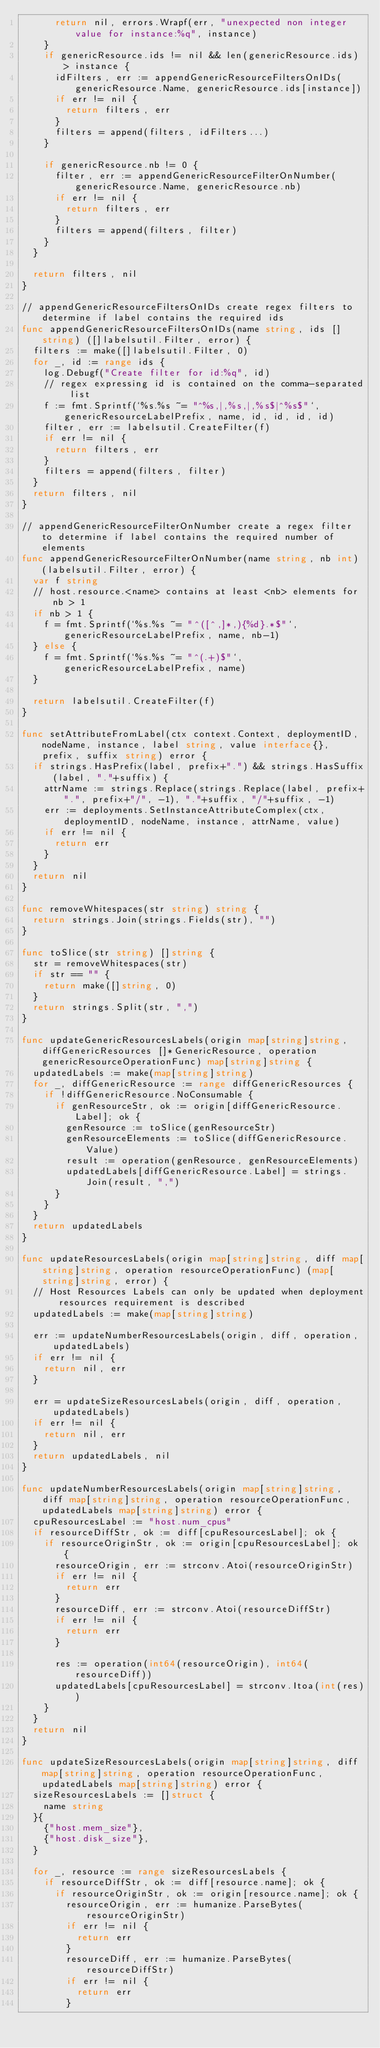<code> <loc_0><loc_0><loc_500><loc_500><_Go_>			return nil, errors.Wrapf(err, "unexpected non integer value for instance:%q", instance)
		}
		if genericResource.ids != nil && len(genericResource.ids) > instance {
			idFilters, err := appendGenericResourceFiltersOnIDs(genericResource.Name, genericResource.ids[instance])
			if err != nil {
				return filters, err
			}
			filters = append(filters, idFilters...)
		}

		if genericResource.nb != 0 {
			filter, err := appendGenericResourceFilterOnNumber(genericResource.Name, genericResource.nb)
			if err != nil {
				return filters, err
			}
			filters = append(filters, filter)
		}
	}

	return filters, nil
}

// appendGenericResourceFiltersOnIDs create regex filters to determine if label contains the required ids
func appendGenericResourceFiltersOnIDs(name string, ids []string) ([]labelsutil.Filter, error) {
	filters := make([]labelsutil.Filter, 0)
	for _, id := range ids {
		log.Debugf("Create filter for id:%q", id)
		// regex expressing id is contained on the comma-separated list
		f := fmt.Sprintf(`%s.%s ~= "^%s,|,%s,|,%s$|^%s$"`, genericResourceLabelPrefix, name, id, id, id, id)
		filter, err := labelsutil.CreateFilter(f)
		if err != nil {
			return filters, err
		}
		filters = append(filters, filter)
	}
	return filters, nil
}

// appendGenericResourceFilterOnNumber create a regex filter to determine if label contains the required number of elements
func appendGenericResourceFilterOnNumber(name string, nb int) (labelsutil.Filter, error) {
	var f string
	// host.resource.<name> contains at least <nb> elements for nb > 1
	if nb > 1 {
		f = fmt.Sprintf(`%s.%s ~= "^([^,]*,){%d}.*$"`, genericResourceLabelPrefix, name, nb-1)
	} else {
		f = fmt.Sprintf(`%s.%s ~= "^(.+)$"`, genericResourceLabelPrefix, name)
	}

	return labelsutil.CreateFilter(f)
}

func setAttributeFromLabel(ctx context.Context, deploymentID, nodeName, instance, label string, value interface{}, prefix, suffix string) error {
	if strings.HasPrefix(label, prefix+".") && strings.HasSuffix(label, "."+suffix) {
		attrName := strings.Replace(strings.Replace(label, prefix+".", prefix+"/", -1), "."+suffix, "/"+suffix, -1)
		err := deployments.SetInstanceAttributeComplex(ctx, deploymentID, nodeName, instance, attrName, value)
		if err != nil {
			return err
		}
	}
	return nil
}

func removeWhitespaces(str string) string {
	return strings.Join(strings.Fields(str), "")
}

func toSlice(str string) []string {
	str = removeWhitespaces(str)
	if str == "" {
		return make([]string, 0)
	}
	return strings.Split(str, ",")
}

func updateGenericResourcesLabels(origin map[string]string, diffGenericResources []*GenericResource, operation genericResourceOperationFunc) map[string]string {
	updatedLabels := make(map[string]string)
	for _, diffGenericResource := range diffGenericResources {
		if !diffGenericResource.NoConsumable {
			if genResourceStr, ok := origin[diffGenericResource.Label]; ok {
				genResource := toSlice(genResourceStr)
				genResourceElements := toSlice(diffGenericResource.Value)
				result := operation(genResource, genResourceElements)
				updatedLabels[diffGenericResource.Label] = strings.Join(result, ",")
			}
		}
	}
	return updatedLabels
}

func updateResourcesLabels(origin map[string]string, diff map[string]string, operation resourceOperationFunc) (map[string]string, error) {
	// Host Resources Labels can only be updated when deployment resources requirement is described
	updatedLabels := make(map[string]string)

	err := updateNumberResourcesLabels(origin, diff, operation, updatedLabels)
	if err != nil {
		return nil, err
	}

	err = updateSizeResourcesLabels(origin, diff, operation, updatedLabels)
	if err != nil {
		return nil, err
	}
	return updatedLabels, nil
}

func updateNumberResourcesLabels(origin map[string]string, diff map[string]string, operation resourceOperationFunc, updatedLabels map[string]string) error {
	cpuResourcesLabel := "host.num_cpus"
	if resourceDiffStr, ok := diff[cpuResourcesLabel]; ok {
		if resourceOriginStr, ok := origin[cpuResourcesLabel]; ok {
			resourceOrigin, err := strconv.Atoi(resourceOriginStr)
			if err != nil {
				return err
			}
			resourceDiff, err := strconv.Atoi(resourceDiffStr)
			if err != nil {
				return err
			}

			res := operation(int64(resourceOrigin), int64(resourceDiff))
			updatedLabels[cpuResourcesLabel] = strconv.Itoa(int(res))
		}
	}
	return nil
}

func updateSizeResourcesLabels(origin map[string]string, diff map[string]string, operation resourceOperationFunc, updatedLabels map[string]string) error {
	sizeResourcesLabels := []struct {
		name string
	}{
		{"host.mem_size"},
		{"host.disk_size"},
	}

	for _, resource := range sizeResourcesLabels {
		if resourceDiffStr, ok := diff[resource.name]; ok {
			if resourceOriginStr, ok := origin[resource.name]; ok {
				resourceOrigin, err := humanize.ParseBytes(resourceOriginStr)
				if err != nil {
					return err
				}
				resourceDiff, err := humanize.ParseBytes(resourceDiffStr)
				if err != nil {
					return err
				}
</code> 